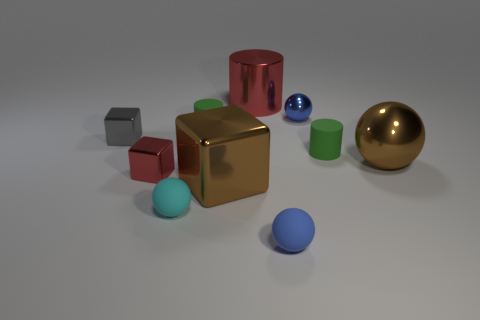Subtract 1 balls. How many balls are left? 3 Subtract all cylinders. How many objects are left? 7 Subtract 1 red blocks. How many objects are left? 9 Subtract all purple metallic blocks. Subtract all gray metal blocks. How many objects are left? 9 Add 5 tiny gray blocks. How many tiny gray blocks are left? 6 Add 10 small green rubber blocks. How many small green rubber blocks exist? 10 